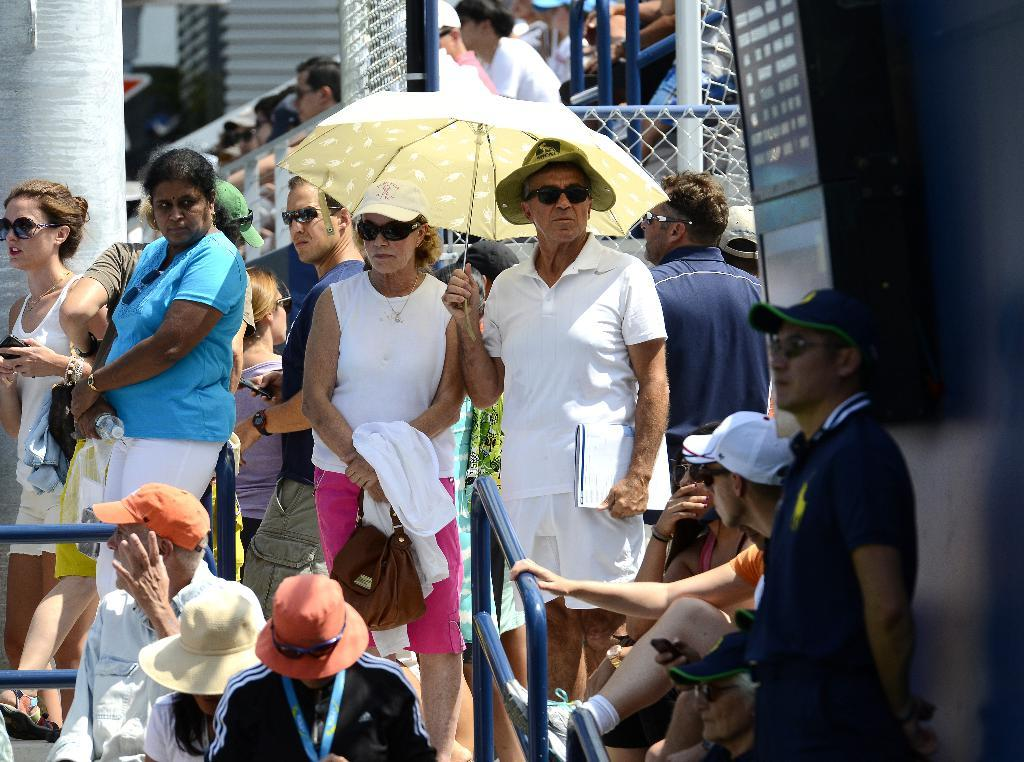How many people are in the image? There is a group of people in the image, but the exact number is not specified. What are the people in the image doing? Some people are sitting, while others are standing. Can you describe the person holding an umbrella in the image? Yes, there is a person holding an umbrella in the image. What can be seen in the background of the image? There are buildings visible in the background of the image. What type of toothbrush is being used by the person holding the umbrella in the image? There is no toothbrush present in the image; the person holding the umbrella is not using a toothbrush. 